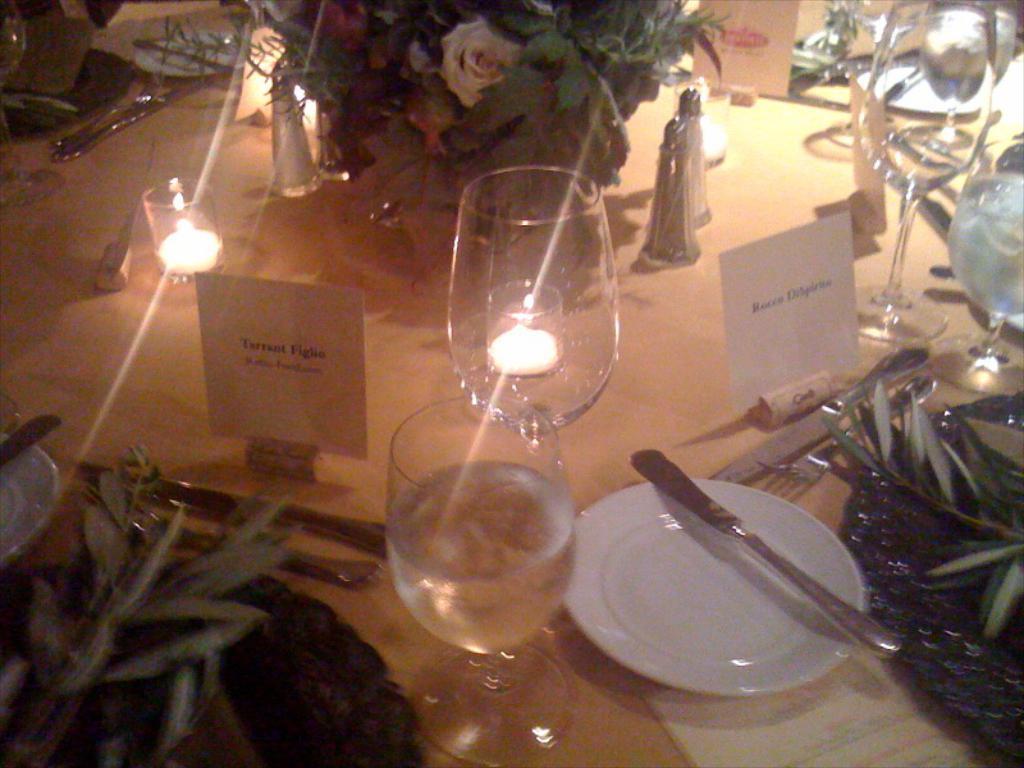Can you describe this image briefly? In the middle of the image there is a table on the table there are some candles and there are some glasses and there are some plates, spoons, forks. Top of the image there is a bouquet. 